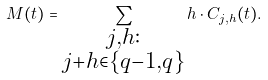Convert formula to latex. <formula><loc_0><loc_0><loc_500><loc_500>M ( t ) = \sum _ { \substack { j , h \colon \\ j + h \in \{ q - 1 , q \} } } h \cdot C _ { j , h } ( t ) .</formula> 